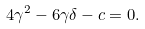Convert formula to latex. <formula><loc_0><loc_0><loc_500><loc_500>4 \gamma ^ { 2 } - 6 \gamma \delta - c = 0 .</formula> 